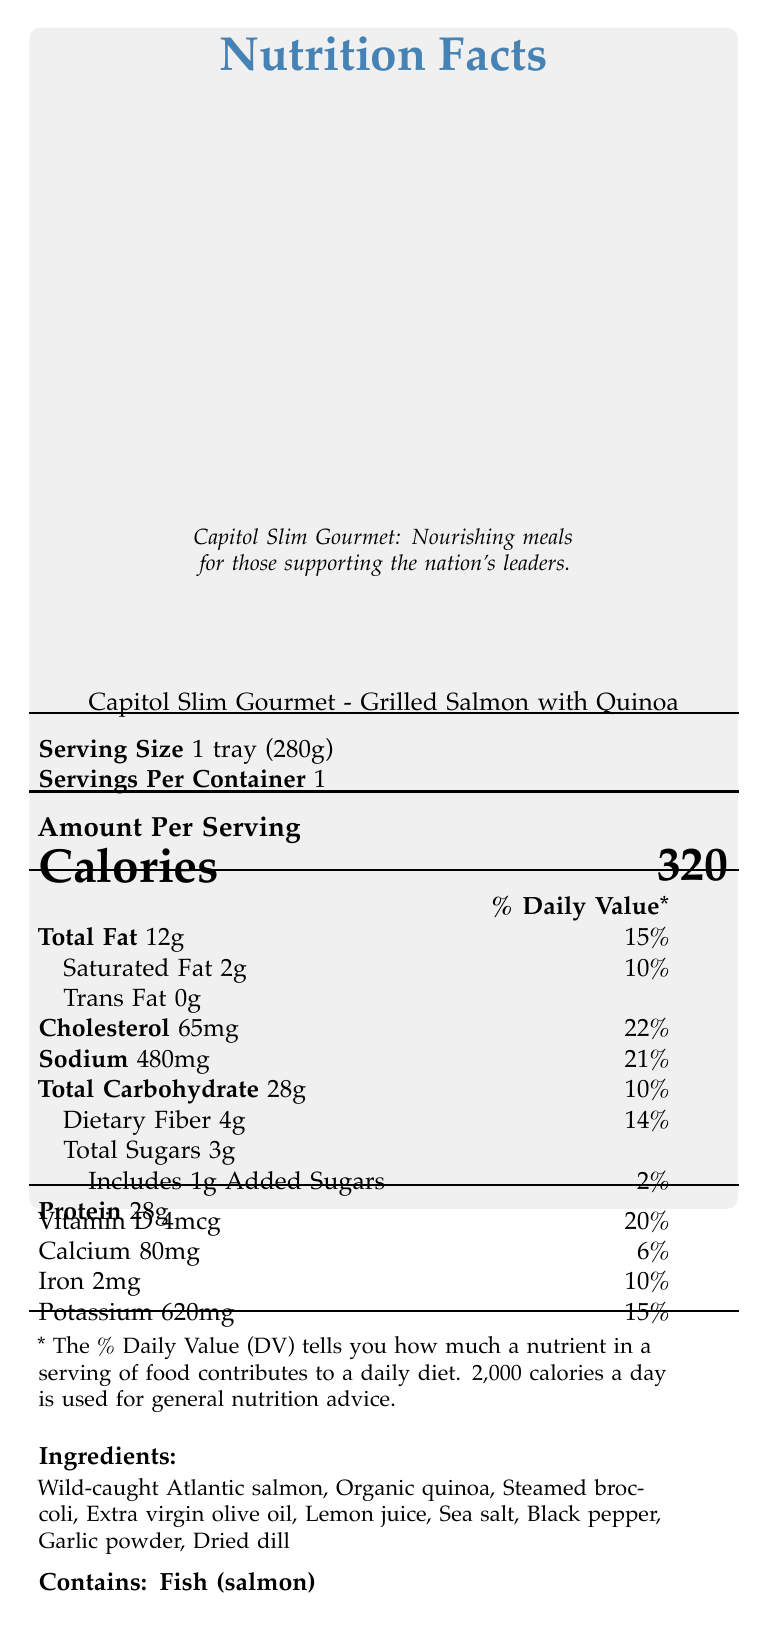What is the serving size? The serving size listed in the document is 1 tray (280g).
Answer: 1 tray (280g) How many calories are in one serving? The document states that there are 320 calories per serving.
Answer: 320 What is the daily value percentage of cholesterol per serving? The document specifies that the daily value percentage of cholesterol per serving is 22%.
Answer: 22% How much protein does the meal provide? The document lists the amount of protein as 28g per serving.
Answer: 28g Which ingredient is listed first? The first ingredient listed is Wild-caught Atlantic salmon, indicating it is the primary ingredient.
Answer: Wild-caught Atlantic salmon Which of the following is a nutrient NOT present in this meal? A. Vitamin C B. Iron C. Calcium D. Vitamin D Vitamin C is not listed among the nutrients, while Iron, Calcium, and Vitamin D are.
Answer: A. Vitamin C What is the main source of fat in this meal? A. Olive Oil B. Butter C. Salmon D. Quinoa Given that salmon is the main ingredient, it is the primary source of fat in this meal, supported by its claim of being rich in omega-3 fatty acids typical of fish.
Answer: C. Salmon Is this meal high in protein? The meal has 28g of protein which is considered high, and the claim "High in protein" supports this.
Answer: Yes Summarize the contents of this document. The document provides detailed nutritional information, with serving size, calories, various nutrients, ingredients, claims about the meal's health benefits, and instructions on how to prepare the meal.
Answer: The document outlines the Nutrition Facts for Capitol Slim Gourmet - Grilled Salmon with Quinoa. It includes information on serving size, calories, macronutrient breakdown, vitamins, and minerals. It lists ingredients, contains claims like "Low in saturated fat" and details cooking instructions. What is the exact amount of sodium in this meal? The document specifies that there are 480mg of sodium per serving.
Answer: 480mg Does the meal contain any gluten? The document claims "Gluten-free," indicating that the meal does not contain gluten.
Answer: No Can you tell me the exact amount of added sugars from the visual information? The document specifies that there are 1g of added sugars per serving.
Answer: Yes, 1g Does this meal contain dairy products? The document does not provide specific information about the presence of dairy products.
Answer: Cannot be determined What are the preparation instructions? The document instructs to microwave the meal on high for 3-4 minutes or until heated through, and then let it stand for 1 minute before serving.
Answer: Microwave on high for 3-4 minutes or until heated through. Let stand for 1 minute before serving. 